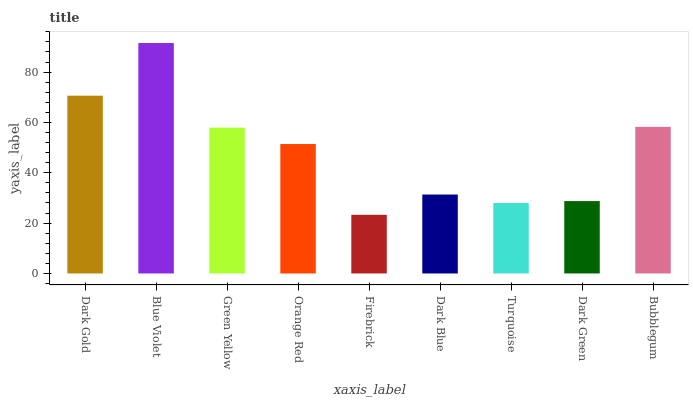Is Firebrick the minimum?
Answer yes or no. Yes. Is Blue Violet the maximum?
Answer yes or no. Yes. Is Green Yellow the minimum?
Answer yes or no. No. Is Green Yellow the maximum?
Answer yes or no. No. Is Blue Violet greater than Green Yellow?
Answer yes or no. Yes. Is Green Yellow less than Blue Violet?
Answer yes or no. Yes. Is Green Yellow greater than Blue Violet?
Answer yes or no. No. Is Blue Violet less than Green Yellow?
Answer yes or no. No. Is Orange Red the high median?
Answer yes or no. Yes. Is Orange Red the low median?
Answer yes or no. Yes. Is Dark Blue the high median?
Answer yes or no. No. Is Firebrick the low median?
Answer yes or no. No. 